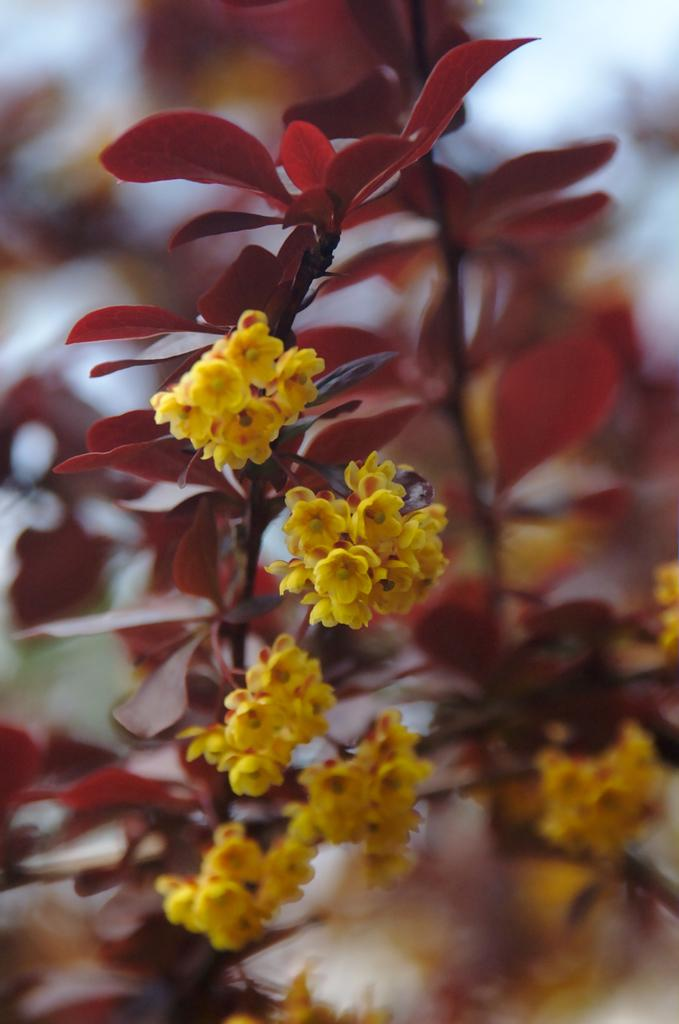What type of plants can be seen in the image? There are flowering plants in the image. What color crayon is being used to draw on the hospital walls in the image? There is no mention of a crayon, drawing, or hospital in the image, so this question cannot be answered. 